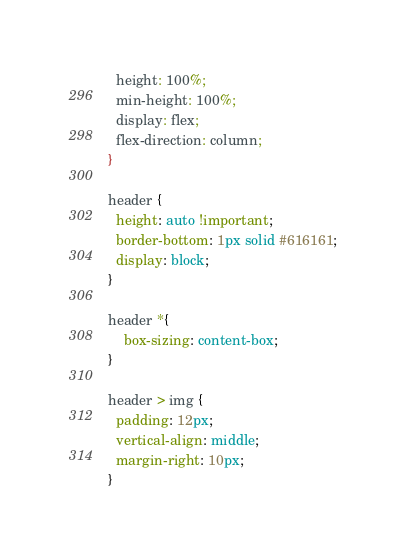<code> <loc_0><loc_0><loc_500><loc_500><_CSS_>  height: 100%;
  min-height: 100%;
  display: flex;
  flex-direction: column;
}

header {
  height: auto !important;
  border-bottom: 1px solid #616161;
  display: block;
}

header *{
	box-sizing: content-box;
}

header > img {
  padding: 12px;
  vertical-align: middle;
  margin-right: 10px;
}
</code> 